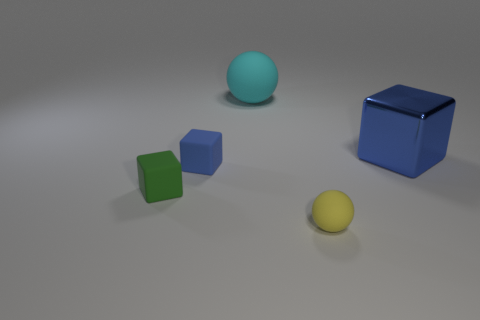Subtract all brown cubes. Subtract all gray balls. How many cubes are left? 3 Add 1 tiny red balls. How many objects exist? 6 Subtract all balls. How many objects are left? 3 Subtract all big blue shiny blocks. Subtract all blue matte things. How many objects are left? 3 Add 2 blue matte cubes. How many blue matte cubes are left? 3 Add 5 large yellow cylinders. How many large yellow cylinders exist? 5 Subtract 0 red balls. How many objects are left? 5 